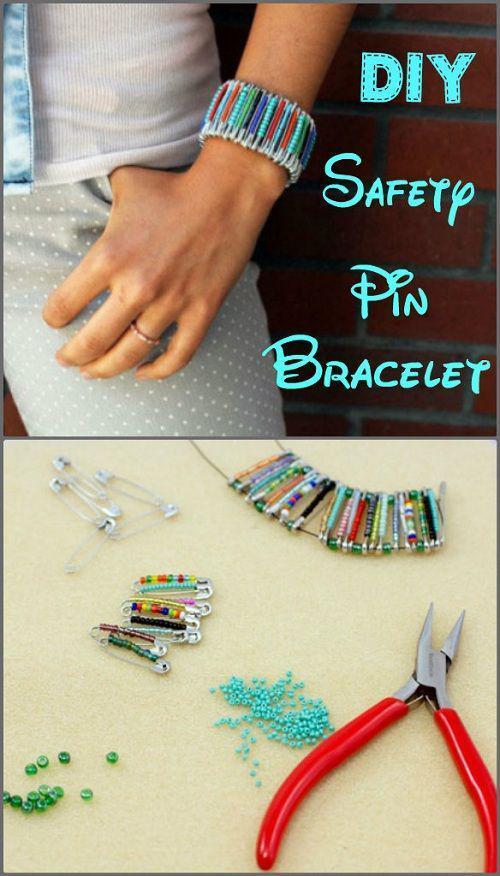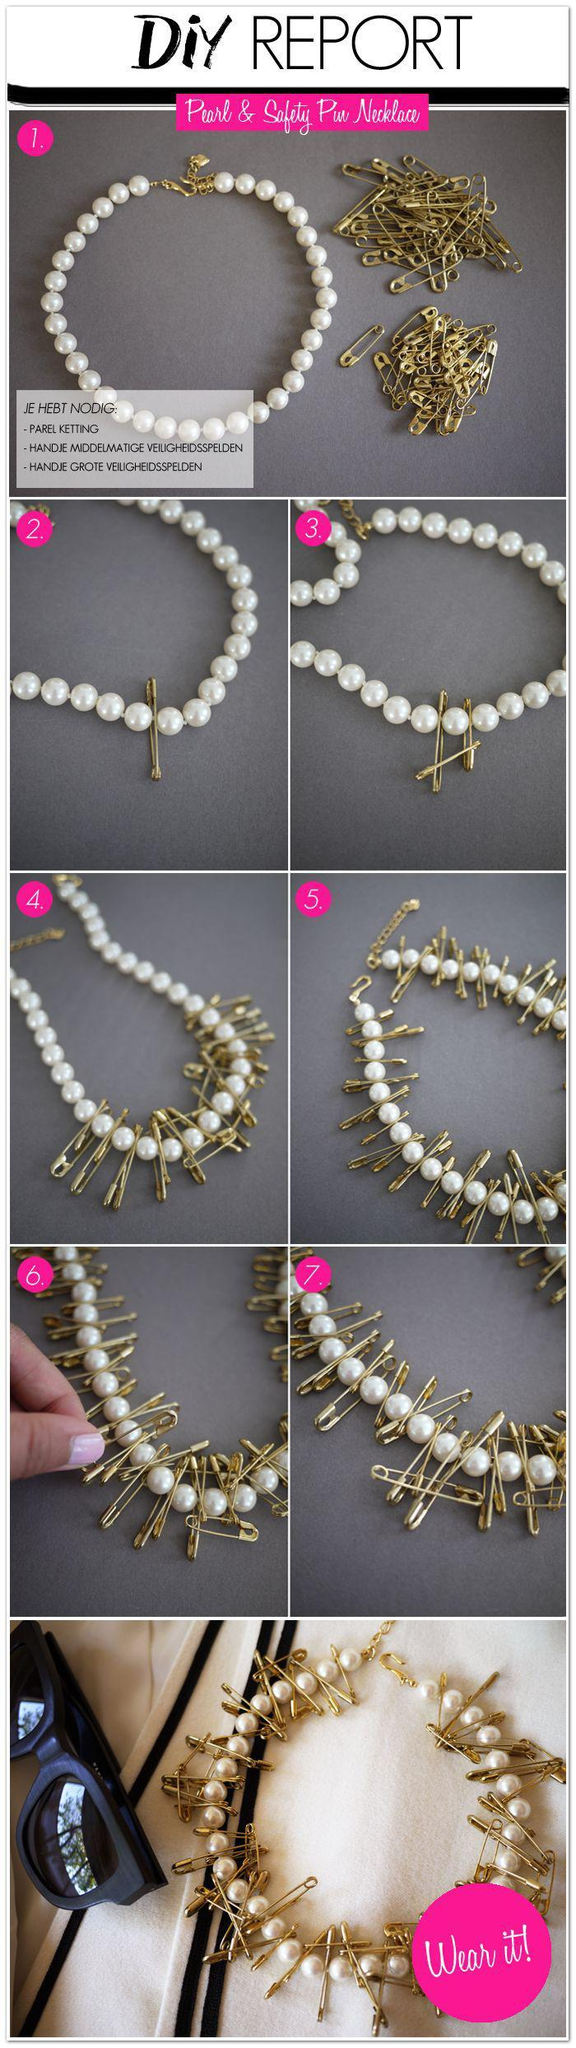The first image is the image on the left, the second image is the image on the right. For the images shown, is this caption "Some safety pins are strung with beads that create heart shapes." true? Answer yes or no. No. The first image is the image on the left, the second image is the image on the right. Given the left and right images, does the statement "The pins in the image on the left show hearts." hold true? Answer yes or no. No. 